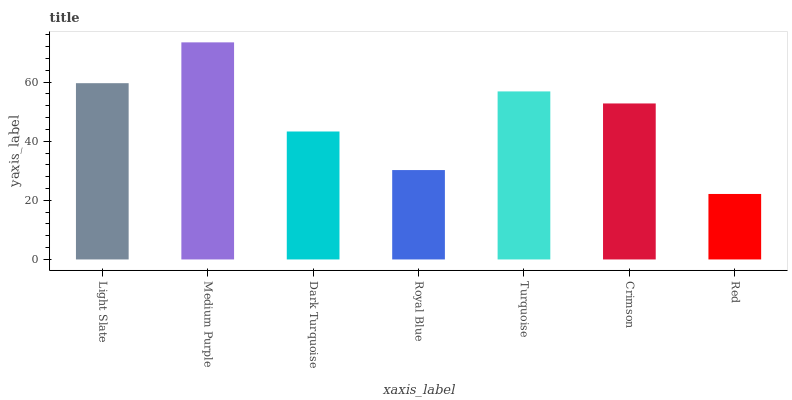Is Red the minimum?
Answer yes or no. Yes. Is Medium Purple the maximum?
Answer yes or no. Yes. Is Dark Turquoise the minimum?
Answer yes or no. No. Is Dark Turquoise the maximum?
Answer yes or no. No. Is Medium Purple greater than Dark Turquoise?
Answer yes or no. Yes. Is Dark Turquoise less than Medium Purple?
Answer yes or no. Yes. Is Dark Turquoise greater than Medium Purple?
Answer yes or no. No. Is Medium Purple less than Dark Turquoise?
Answer yes or no. No. Is Crimson the high median?
Answer yes or no. Yes. Is Crimson the low median?
Answer yes or no. Yes. Is Royal Blue the high median?
Answer yes or no. No. Is Light Slate the low median?
Answer yes or no. No. 